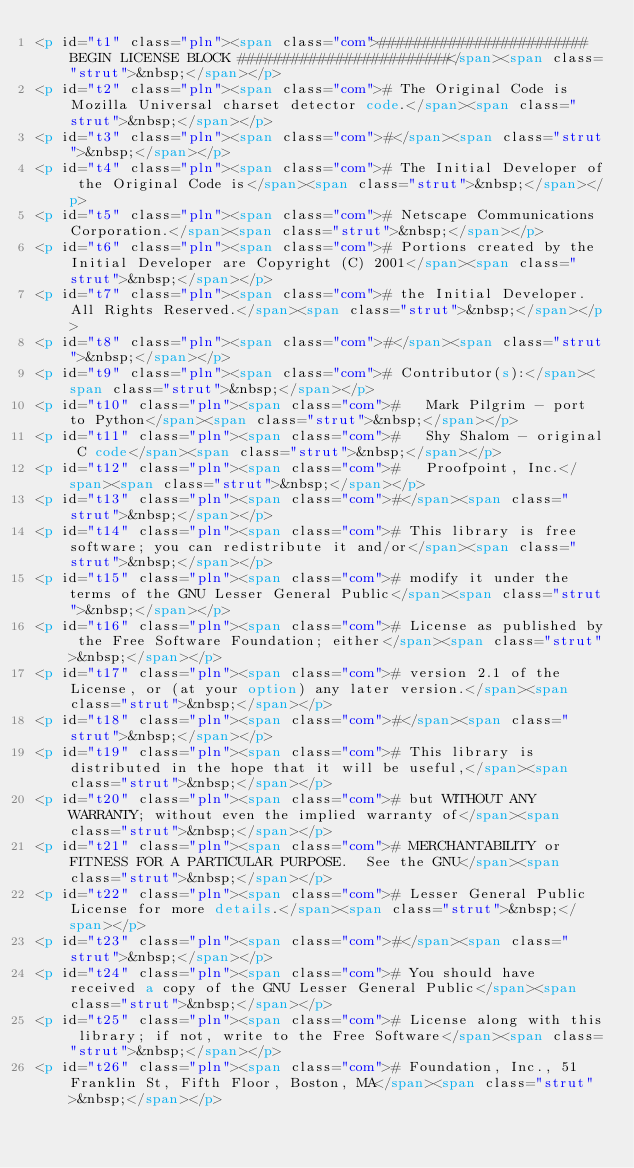<code> <loc_0><loc_0><loc_500><loc_500><_HTML_><p id="t1" class="pln"><span class="com">######################## BEGIN LICENSE BLOCK ########################</span><span class="strut">&nbsp;</span></p>
<p id="t2" class="pln"><span class="com"># The Original Code is Mozilla Universal charset detector code.</span><span class="strut">&nbsp;</span></p>
<p id="t3" class="pln"><span class="com">#</span><span class="strut">&nbsp;</span></p>
<p id="t4" class="pln"><span class="com"># The Initial Developer of the Original Code is</span><span class="strut">&nbsp;</span></p>
<p id="t5" class="pln"><span class="com"># Netscape Communications Corporation.</span><span class="strut">&nbsp;</span></p>
<p id="t6" class="pln"><span class="com"># Portions created by the Initial Developer are Copyright (C) 2001</span><span class="strut">&nbsp;</span></p>
<p id="t7" class="pln"><span class="com"># the Initial Developer. All Rights Reserved.</span><span class="strut">&nbsp;</span></p>
<p id="t8" class="pln"><span class="com">#</span><span class="strut">&nbsp;</span></p>
<p id="t9" class="pln"><span class="com"># Contributor(s):</span><span class="strut">&nbsp;</span></p>
<p id="t10" class="pln"><span class="com">#   Mark Pilgrim - port to Python</span><span class="strut">&nbsp;</span></p>
<p id="t11" class="pln"><span class="com">#   Shy Shalom - original C code</span><span class="strut">&nbsp;</span></p>
<p id="t12" class="pln"><span class="com">#   Proofpoint, Inc.</span><span class="strut">&nbsp;</span></p>
<p id="t13" class="pln"><span class="com">#</span><span class="strut">&nbsp;</span></p>
<p id="t14" class="pln"><span class="com"># This library is free software; you can redistribute it and/or</span><span class="strut">&nbsp;</span></p>
<p id="t15" class="pln"><span class="com"># modify it under the terms of the GNU Lesser General Public</span><span class="strut">&nbsp;</span></p>
<p id="t16" class="pln"><span class="com"># License as published by the Free Software Foundation; either</span><span class="strut">&nbsp;</span></p>
<p id="t17" class="pln"><span class="com"># version 2.1 of the License, or (at your option) any later version.</span><span class="strut">&nbsp;</span></p>
<p id="t18" class="pln"><span class="com">#</span><span class="strut">&nbsp;</span></p>
<p id="t19" class="pln"><span class="com"># This library is distributed in the hope that it will be useful,</span><span class="strut">&nbsp;</span></p>
<p id="t20" class="pln"><span class="com"># but WITHOUT ANY WARRANTY; without even the implied warranty of</span><span class="strut">&nbsp;</span></p>
<p id="t21" class="pln"><span class="com"># MERCHANTABILITY or FITNESS FOR A PARTICULAR PURPOSE.  See the GNU</span><span class="strut">&nbsp;</span></p>
<p id="t22" class="pln"><span class="com"># Lesser General Public License for more details.</span><span class="strut">&nbsp;</span></p>
<p id="t23" class="pln"><span class="com">#</span><span class="strut">&nbsp;</span></p>
<p id="t24" class="pln"><span class="com"># You should have received a copy of the GNU Lesser General Public</span><span class="strut">&nbsp;</span></p>
<p id="t25" class="pln"><span class="com"># License along with this library; if not, write to the Free Software</span><span class="strut">&nbsp;</span></p>
<p id="t26" class="pln"><span class="com"># Foundation, Inc., 51 Franklin St, Fifth Floor, Boston, MA</span><span class="strut">&nbsp;</span></p></code> 